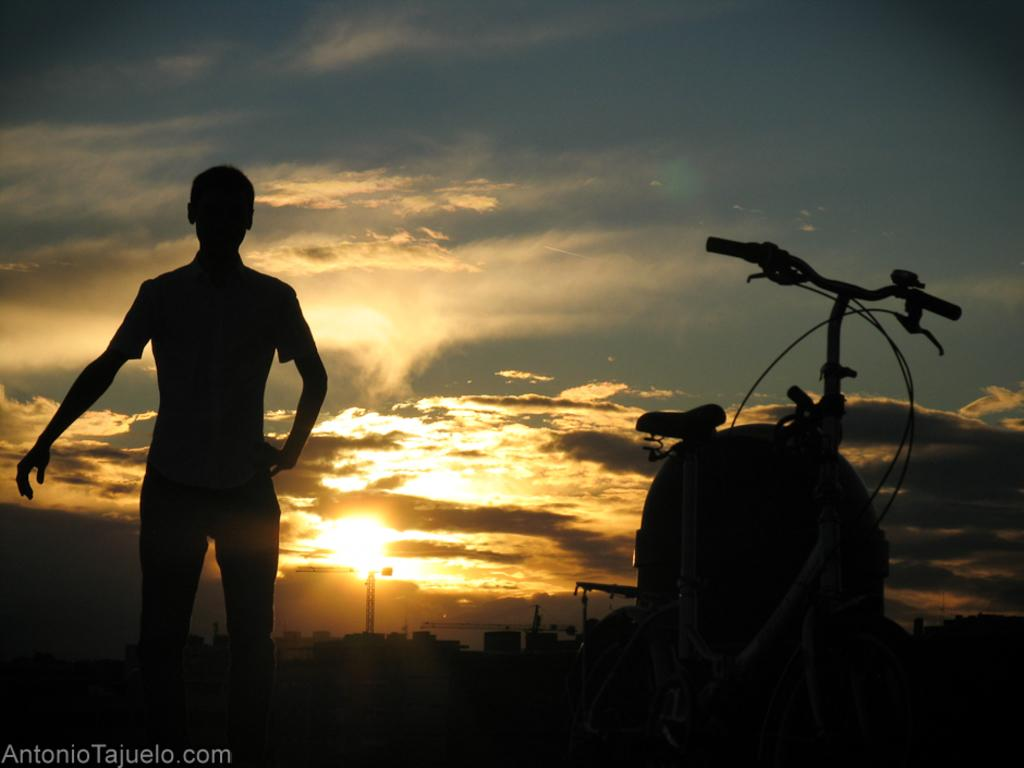What is located in the foreground of the image? There is a bicycle in the foreground of the image. On which side of the image is the bicycle? The bicycle is on the right side of the image. What else can be seen in the foreground of the image? There is a man in the foreground of the image. On which side of the image is the man? The man is on the left side of the image. What is visible in the background of the image? Buildings, a sunset, sky, and a cloud are visible in the background of the image. What type of discovery was made by the minister in the image? There is no minister or discovery present in the image. What is the hole used for in the image? There is no hole present in the image. 